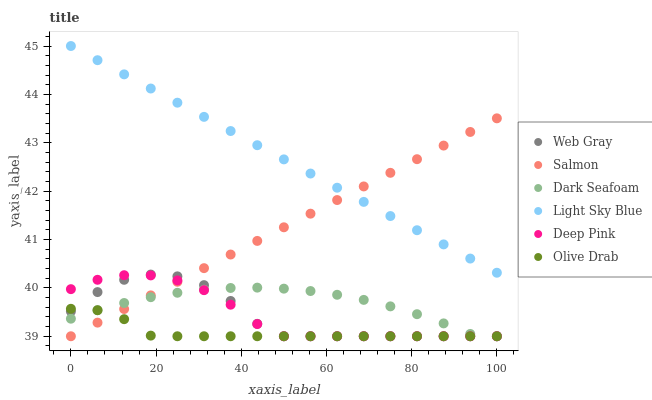Does Olive Drab have the minimum area under the curve?
Answer yes or no. Yes. Does Light Sky Blue have the maximum area under the curve?
Answer yes or no. Yes. Does Salmon have the minimum area under the curve?
Answer yes or no. No. Does Salmon have the maximum area under the curve?
Answer yes or no. No. Is Light Sky Blue the smoothest?
Answer yes or no. Yes. Is Web Gray the roughest?
Answer yes or no. Yes. Is Salmon the smoothest?
Answer yes or no. No. Is Salmon the roughest?
Answer yes or no. No. Does Web Gray have the lowest value?
Answer yes or no. Yes. Does Light Sky Blue have the lowest value?
Answer yes or no. No. Does Light Sky Blue have the highest value?
Answer yes or no. Yes. Does Salmon have the highest value?
Answer yes or no. No. Is Dark Seafoam less than Light Sky Blue?
Answer yes or no. Yes. Is Light Sky Blue greater than Web Gray?
Answer yes or no. Yes. Does Olive Drab intersect Deep Pink?
Answer yes or no. Yes. Is Olive Drab less than Deep Pink?
Answer yes or no. No. Is Olive Drab greater than Deep Pink?
Answer yes or no. No. Does Dark Seafoam intersect Light Sky Blue?
Answer yes or no. No. 